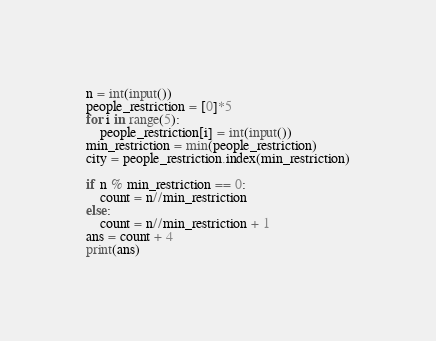<code> <loc_0><loc_0><loc_500><loc_500><_Python_>n = int(input())
people_restriction = [0]*5
for i in range(5):
    people_restriction[i] = int(input())
min_restriction = min(people_restriction)
city = people_restriction.index(min_restriction)

if n % min_restriction == 0:
    count = n//min_restriction
else:
    count = n//min_restriction + 1
ans = count + 4
print(ans)</code> 